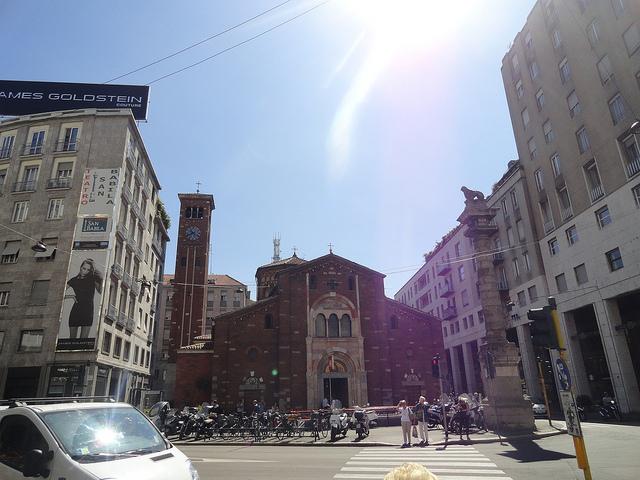What is the billboard in this picture advertising?
Answer briefly. Clothes. What is the weather?
Quick response, please. Sunny. Is there anyone in the crosswalk?
Write a very short answer. Yes. Is this building still used as a church?
Give a very brief answer. Yes. In what direction are the vehicles closest to the viewer traveling?
Give a very brief answer. Right. What is on top of the building on the left?
Be succinct. Sign. What is shining in the background?
Concise answer only. Sun. What does the black billboard say?
Give a very brief answer. James goldstein. Is there a funeral in the middle building?
Short answer required. No. What is the theater straight ahead?
Write a very short answer. Church. 